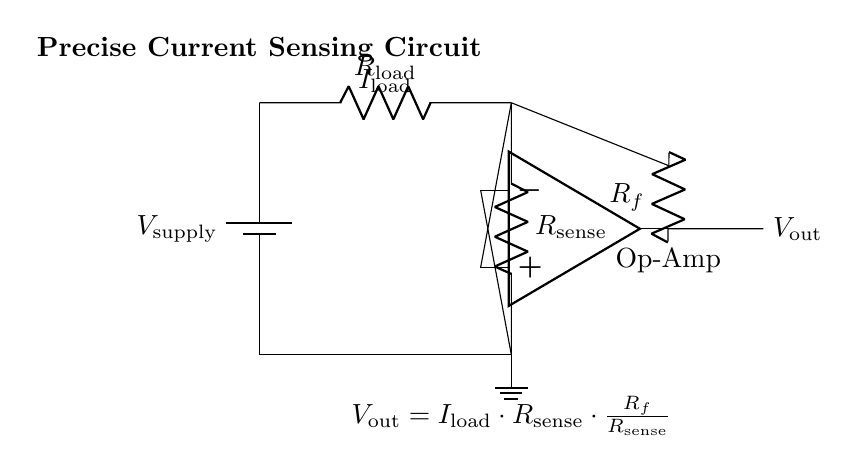What is the supply voltage in this circuit? The supply voltage is indicated on the left side of the circuit where the battery is depicted. It is labeled as \( V_{\text{supply}} \).
Answer: V_supply What is the purpose of the sense resistor? The sense resistor is used to measure the current flowing through the load resistor by creating a voltage drop proportional to the current, which can be amplified by the op-amp.
Answer: Current measurement What component is used to amplify the voltage difference? The operational amplifier (op-amp) is the component used in this circuit to amplify the voltage difference between its non-inverting and inverting inputs.
Answer: Op-amp How is the output voltage related to the load current? The output voltage is expressed by the equation given in the circuit: \( V_{\text{out}} = I_{\text{load}} \cdot R_{\text{sense}} \cdot \frac{R_f}{R_{\text{sense}}} \), which demonstrates that output voltage is proportional to both the load current and the feedback resistor ratio.
Answer: Proportional relationship What effect does changing the feedback resistor have on the output voltage? Changing the feedback resistor \( R_f \) alters the gain of the op-amp circuit, thereby affecting the output voltage based on the load current through the formula provided; increasing \( R_f \) will increase the output voltage.
Answer: Changes output gain What type of circuit is depicted in this diagram? The circuit is classified as a current sensing circuit, as it is specifically designed to measure and amplify the current using a sense resistor and an operational amplifier.
Answer: Current sensing circuit 